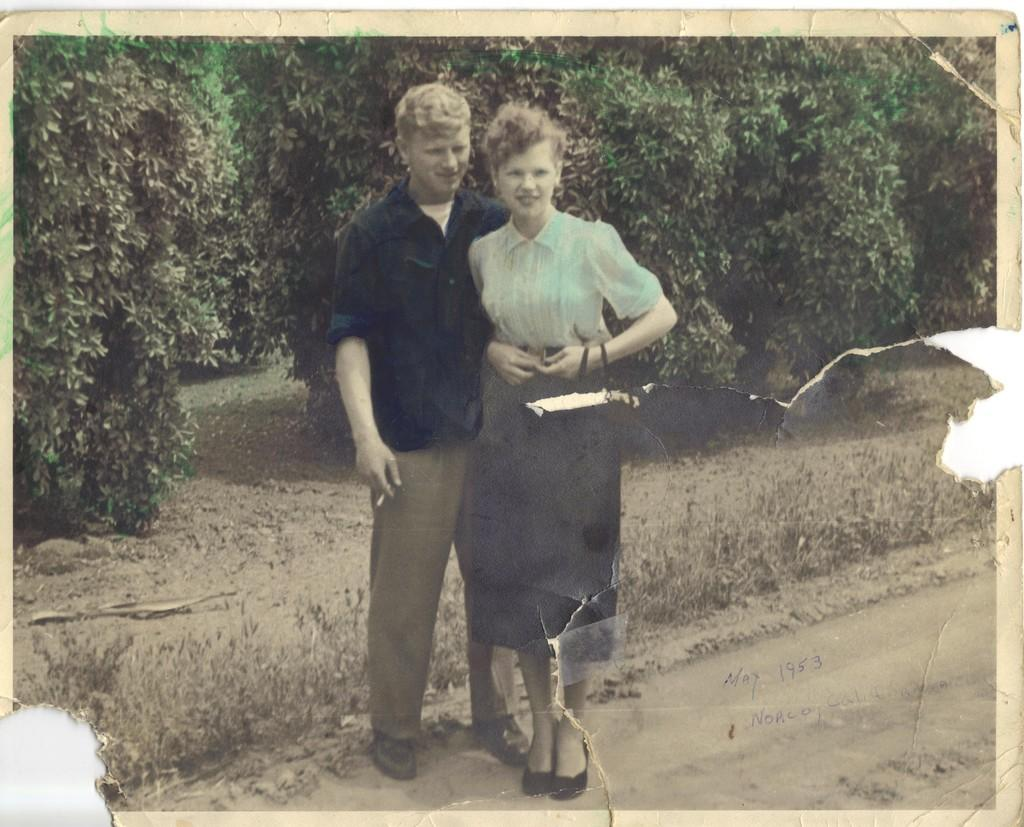What is the main subject of the image? There is a photo in the image. What can be seen in the photo? The photo contains images of two persons. What is visible in the background of the photo? There are trees visible behind the persons in the photo. What time of day is depicted in the photo? The provided facts do not mention the time of day, so it cannot be determined from the image. 